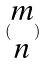<formula> <loc_0><loc_0><loc_500><loc_500>( \begin{matrix} m \\ n \end{matrix} )</formula> 